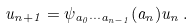<formula> <loc_0><loc_0><loc_500><loc_500>u _ { n + 1 } = \psi _ { a _ { 0 } \cdots a _ { n - 1 } } ( a _ { n } ) u _ { n } \, .</formula> 